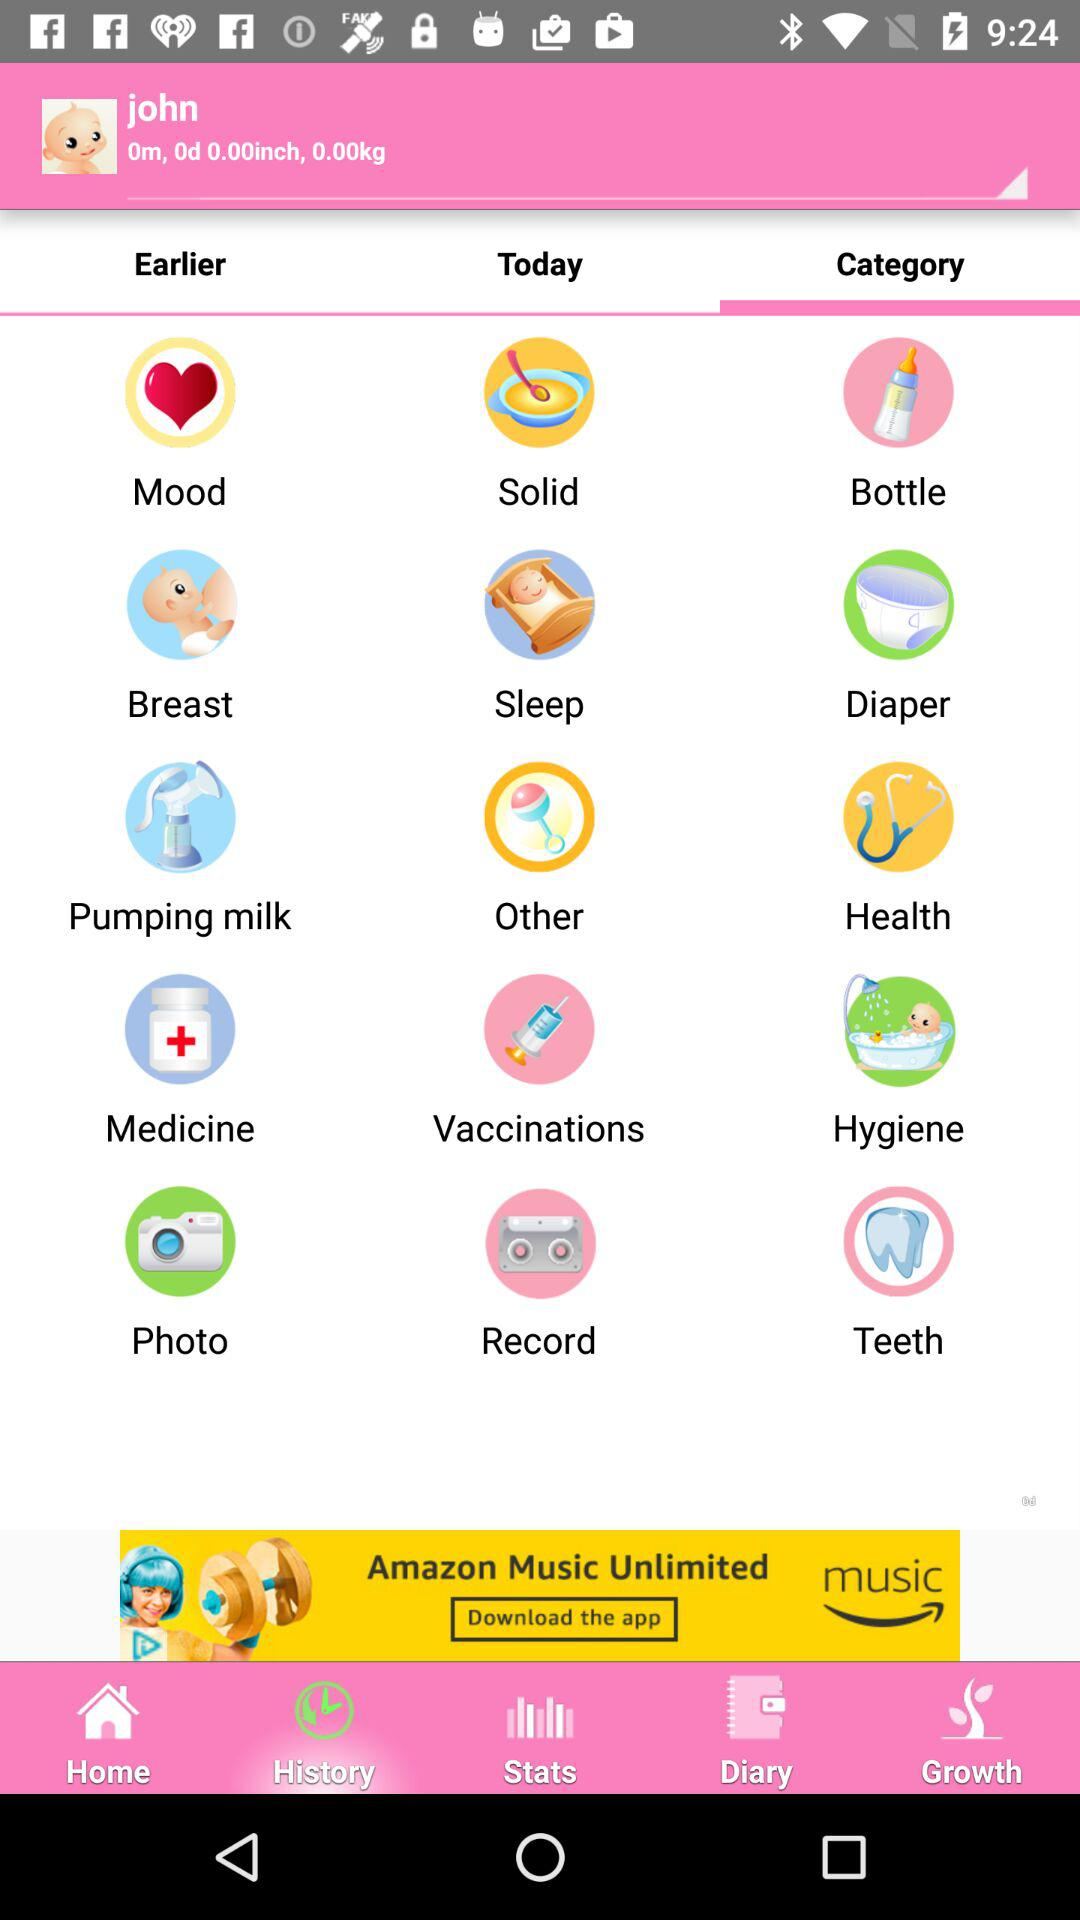What are the names of the categories? The names of the categories are "Mood", "Solid", "Bottle", "Breast", "Sleep", "Diaper", "Pumping milk", "Other", "Health", "Medicine", "Vaccinations", "Hygiene", "Photo", "Record" and "Teeth". 